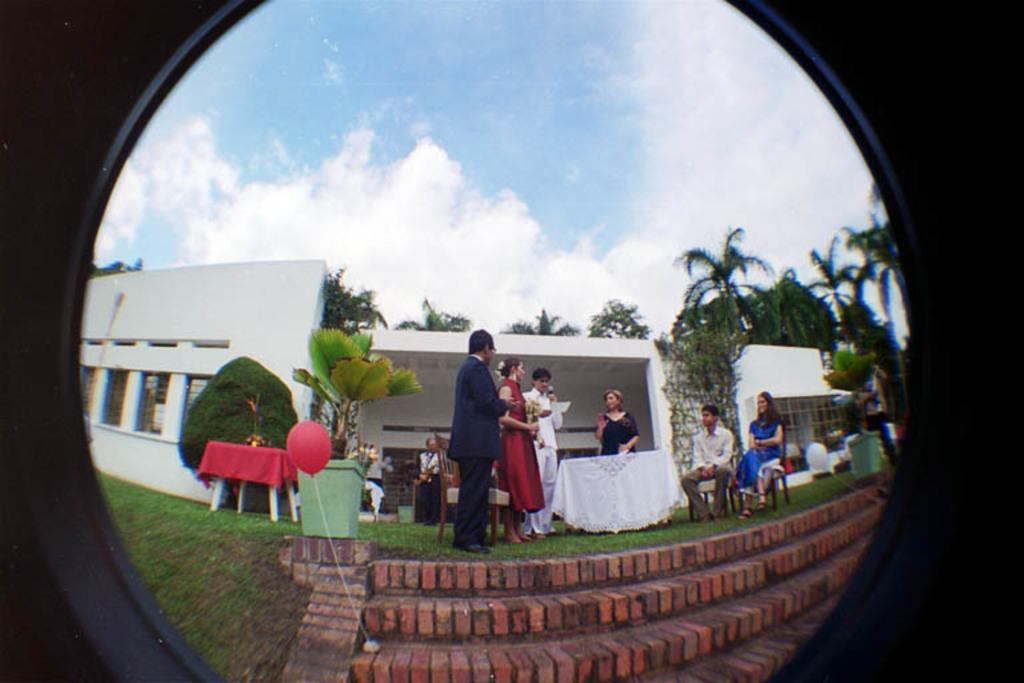Could you give a brief overview of what you see in this image? In this image I can see a round glass through which we can see stairs, a red balloon, people are present and there is a white table in the center. There are plants and grass. There is a white building behind them and there are trees at the back. There is sky at the top. 